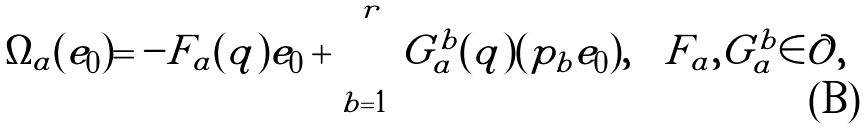<formula> <loc_0><loc_0><loc_500><loc_500>\Omega _ { a } ( e _ { 0 } ) = - F _ { a } ( q ) e _ { 0 } + \sum _ { b = 1 } ^ { r } G ^ { b } _ { a } ( q ) ( p _ { b } e _ { 0 } ) , \quad F _ { a } , G ^ { b } _ { a } \in \mathcal { O } ,</formula> 